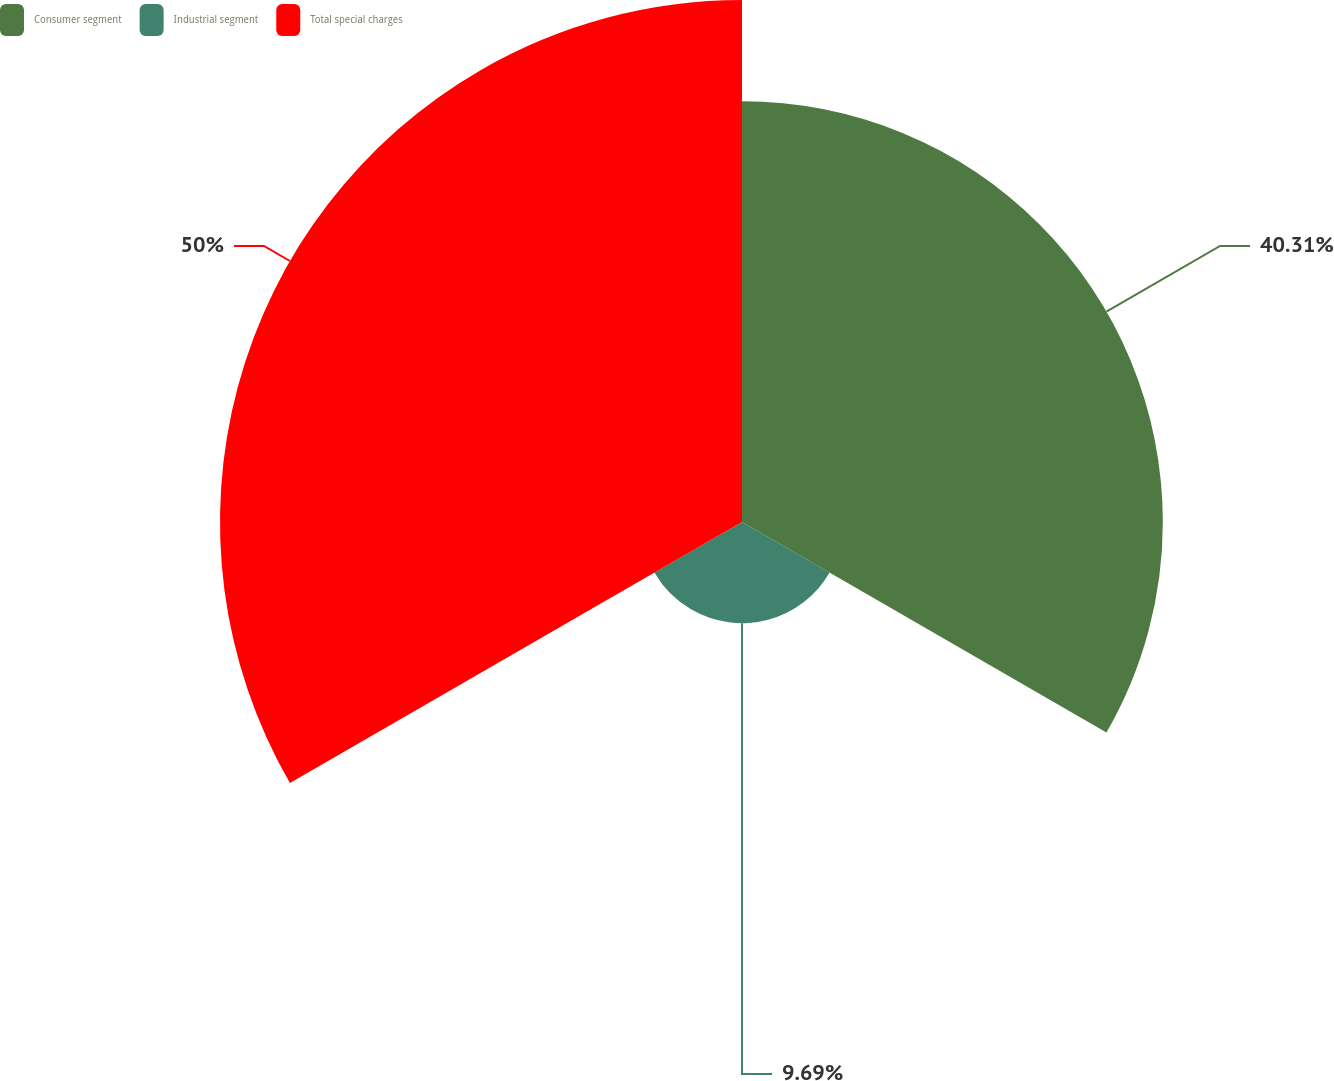Convert chart to OTSL. <chart><loc_0><loc_0><loc_500><loc_500><pie_chart><fcel>Consumer segment<fcel>Industrial segment<fcel>Total special charges<nl><fcel>40.31%<fcel>9.69%<fcel>50.0%<nl></chart> 